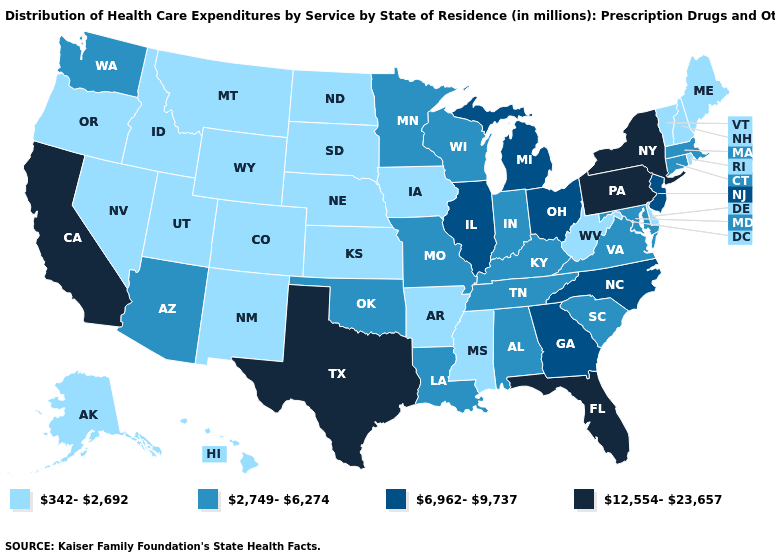Does the map have missing data?
Concise answer only. No. Name the states that have a value in the range 6,962-9,737?
Concise answer only. Georgia, Illinois, Michigan, New Jersey, North Carolina, Ohio. Does Ohio have the lowest value in the MidWest?
Short answer required. No. Does the map have missing data?
Be succinct. No. Is the legend a continuous bar?
Be succinct. No. Name the states that have a value in the range 12,554-23,657?
Answer briefly. California, Florida, New York, Pennsylvania, Texas. Which states have the lowest value in the USA?
Give a very brief answer. Alaska, Arkansas, Colorado, Delaware, Hawaii, Idaho, Iowa, Kansas, Maine, Mississippi, Montana, Nebraska, Nevada, New Hampshire, New Mexico, North Dakota, Oregon, Rhode Island, South Dakota, Utah, Vermont, West Virginia, Wyoming. Which states have the highest value in the USA?
Write a very short answer. California, Florida, New York, Pennsylvania, Texas. Does Texas have the lowest value in the USA?
Short answer required. No. What is the value of Arizona?
Give a very brief answer. 2,749-6,274. Name the states that have a value in the range 12,554-23,657?
Quick response, please. California, Florida, New York, Pennsylvania, Texas. Name the states that have a value in the range 12,554-23,657?
Concise answer only. California, Florida, New York, Pennsylvania, Texas. What is the value of Pennsylvania?
Answer briefly. 12,554-23,657. Among the states that border Missouri , which have the highest value?
Give a very brief answer. Illinois. Name the states that have a value in the range 6,962-9,737?
Write a very short answer. Georgia, Illinois, Michigan, New Jersey, North Carolina, Ohio. 